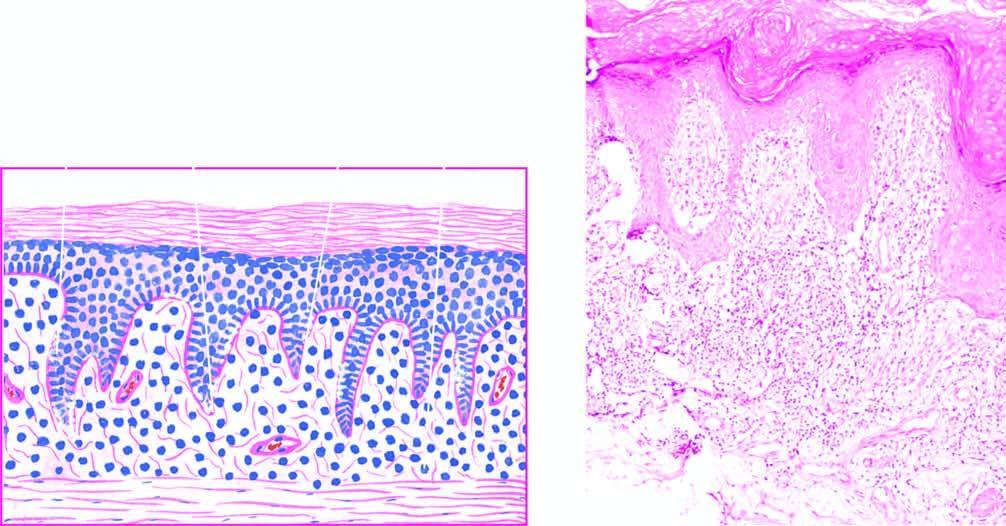does the basal layer show liquefactive degeneration?
Answer the question using a single word or phrase. Yes 